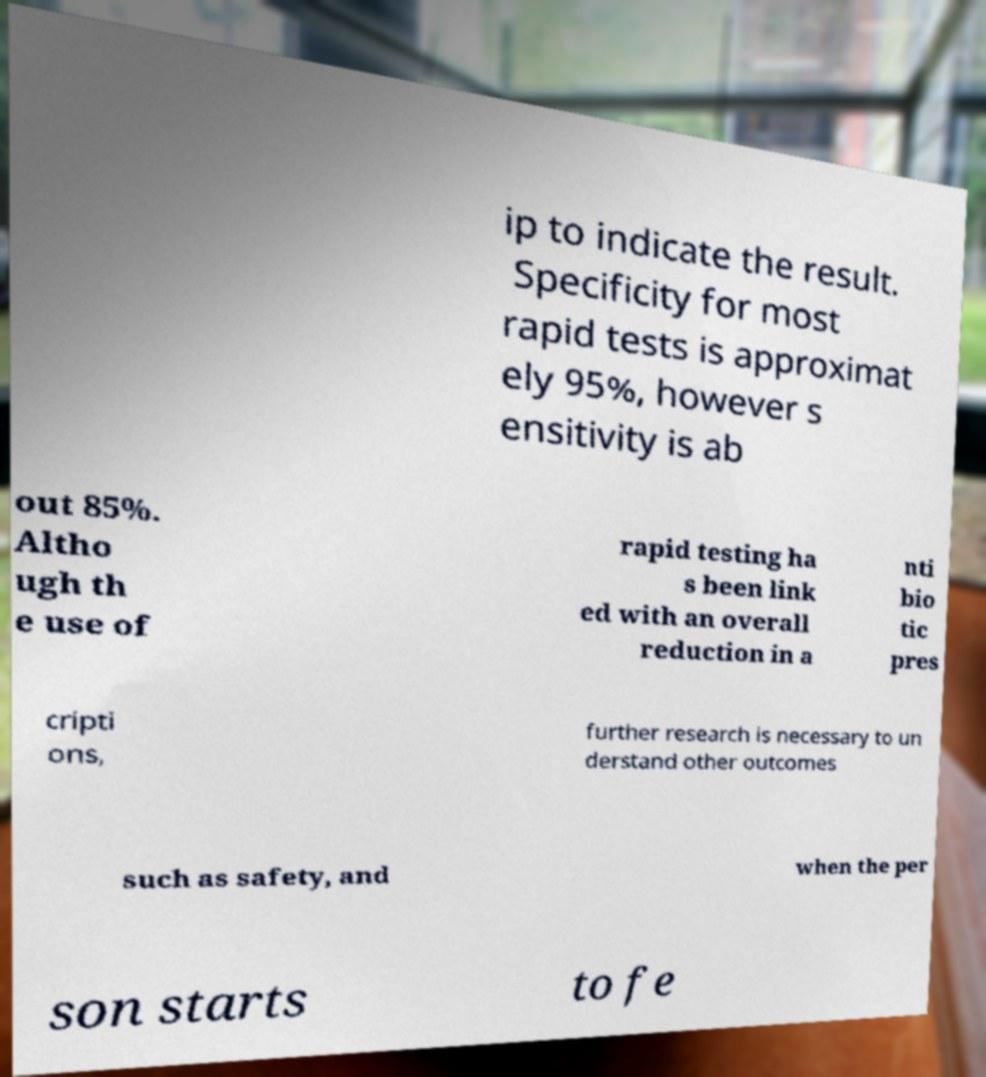What messages or text are displayed in this image? I need them in a readable, typed format. ip to indicate the result. Specificity for most rapid tests is approximat ely 95%, however s ensitivity is ab out 85%. Altho ugh th e use of rapid testing ha s been link ed with an overall reduction in a nti bio tic pres cripti ons, further research is necessary to un derstand other outcomes such as safety, and when the per son starts to fe 